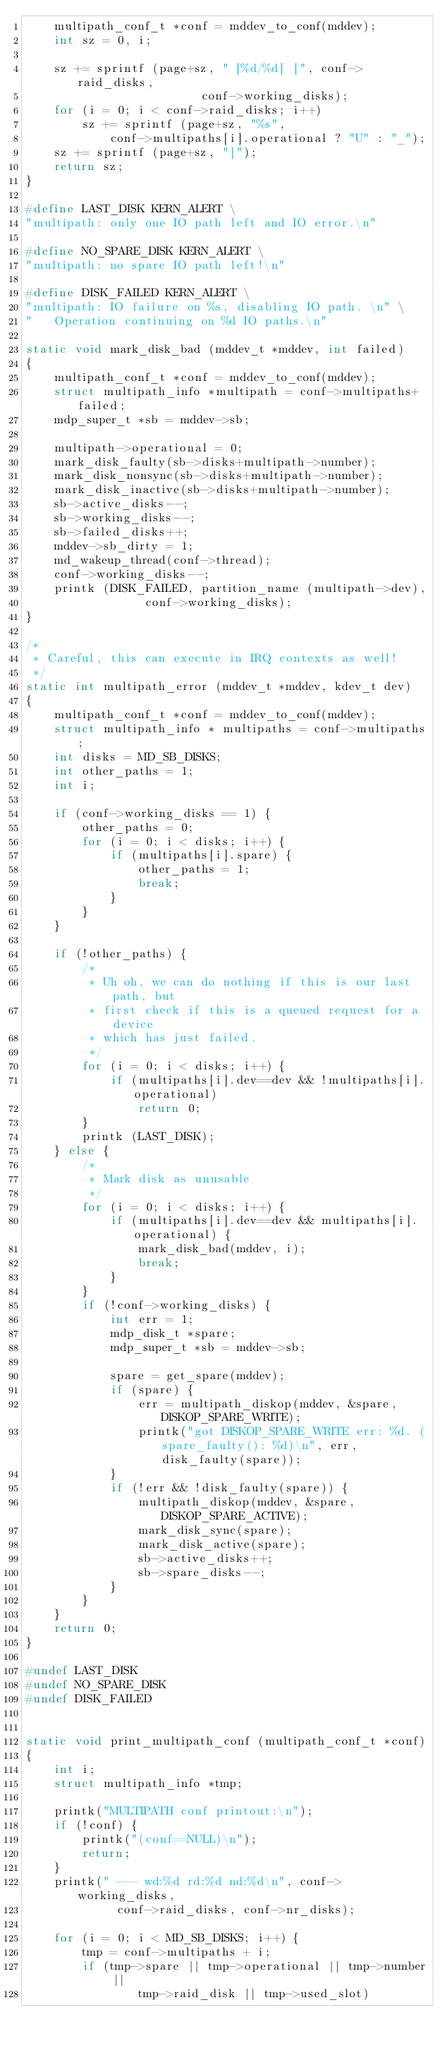<code> <loc_0><loc_0><loc_500><loc_500><_C_>	multipath_conf_t *conf = mddev_to_conf(mddev);
	int sz = 0, i;
	
	sz += sprintf (page+sz, " [%d/%d] [", conf->raid_disks,
						 conf->working_disks);
	for (i = 0; i < conf->raid_disks; i++)
		sz += sprintf (page+sz, "%s",
			conf->multipaths[i].operational ? "U" : "_");
	sz += sprintf (page+sz, "]");
	return sz;
}

#define LAST_DISK KERN_ALERT \
"multipath: only one IO path left and IO error.\n"

#define NO_SPARE_DISK KERN_ALERT \
"multipath: no spare IO path left!\n"

#define DISK_FAILED KERN_ALERT \
"multipath: IO failure on %s, disabling IO path. \n" \
"	Operation continuing on %d IO paths.\n"

static void mark_disk_bad (mddev_t *mddev, int failed)
{
	multipath_conf_t *conf = mddev_to_conf(mddev);
	struct multipath_info *multipath = conf->multipaths+failed;
	mdp_super_t *sb = mddev->sb;

	multipath->operational = 0;
	mark_disk_faulty(sb->disks+multipath->number);
	mark_disk_nonsync(sb->disks+multipath->number);
	mark_disk_inactive(sb->disks+multipath->number);
	sb->active_disks--;
	sb->working_disks--;
	sb->failed_disks++;
	mddev->sb_dirty = 1;
	md_wakeup_thread(conf->thread);
	conf->working_disks--;
	printk (DISK_FAILED, partition_name (multipath->dev),
				 conf->working_disks);
}

/*
 * Careful, this can execute in IRQ contexts as well!
 */
static int multipath_error (mddev_t *mddev, kdev_t dev)
{
	multipath_conf_t *conf = mddev_to_conf(mddev);
	struct multipath_info * multipaths = conf->multipaths;
	int disks = MD_SB_DISKS;
	int other_paths = 1;
	int i;

	if (conf->working_disks == 1) {
		other_paths = 0;
		for (i = 0; i < disks; i++) {
			if (multipaths[i].spare) {
				other_paths = 1;
				break;
			}
		}
	}

	if (!other_paths) {
		/*
		 * Uh oh, we can do nothing if this is our last path, but
		 * first check if this is a queued request for a device
		 * which has just failed.
		 */
		for (i = 0; i < disks; i++) {
			if (multipaths[i].dev==dev && !multipaths[i].operational)
				return 0;
		}
		printk (LAST_DISK);
	} else {
		/*
		 * Mark disk as unusable
		 */
		for (i = 0; i < disks; i++) {
			if (multipaths[i].dev==dev && multipaths[i].operational) {
				mark_disk_bad(mddev, i);
				break;
			}
		}
		if (!conf->working_disks) {
			int err = 1;
			mdp_disk_t *spare;
			mdp_super_t *sb = mddev->sb;

			spare = get_spare(mddev);
			if (spare) {
				err = multipath_diskop(mddev, &spare, DISKOP_SPARE_WRITE);
				printk("got DISKOP_SPARE_WRITE err: %d. (spare_faulty(): %d)\n", err, disk_faulty(spare));
			}
			if (!err && !disk_faulty(spare)) {
				multipath_diskop(mddev, &spare, DISKOP_SPARE_ACTIVE);
				mark_disk_sync(spare);
				mark_disk_active(spare);
				sb->active_disks++;
				sb->spare_disks--;
			}
		}
	}
	return 0;
}

#undef LAST_DISK
#undef NO_SPARE_DISK
#undef DISK_FAILED


static void print_multipath_conf (multipath_conf_t *conf)
{
	int i;
	struct multipath_info *tmp;

	printk("MULTIPATH conf printout:\n");
	if (!conf) {
		printk("(conf==NULL)\n");
		return;
	}
	printk(" --- wd:%d rd:%d nd:%d\n", conf->working_disks,
			 conf->raid_disks, conf->nr_disks);

	for (i = 0; i < MD_SB_DISKS; i++) {
		tmp = conf->multipaths + i;
		if (tmp->spare || tmp->operational || tmp->number ||
				tmp->raid_disk || tmp->used_slot)</code> 